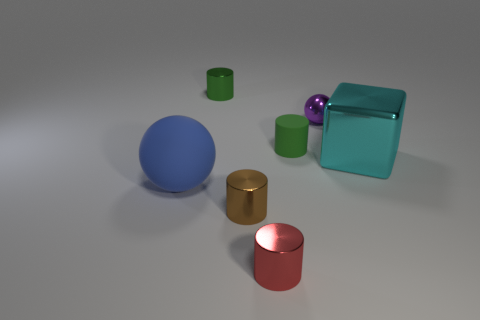Subtract all tiny metal cylinders. How many cylinders are left? 1 Subtract all blue balls. How many balls are left? 1 Add 2 small red metal objects. How many objects exist? 9 Subtract all green balls. How many green cylinders are left? 2 Subtract all spheres. How many objects are left? 5 Subtract all cyan blocks. Subtract all tiny red metal cylinders. How many objects are left? 5 Add 1 green metal objects. How many green metal objects are left? 2 Add 7 green shiny objects. How many green shiny objects exist? 8 Subtract 0 yellow cylinders. How many objects are left? 7 Subtract all blue spheres. Subtract all red cubes. How many spheres are left? 1 